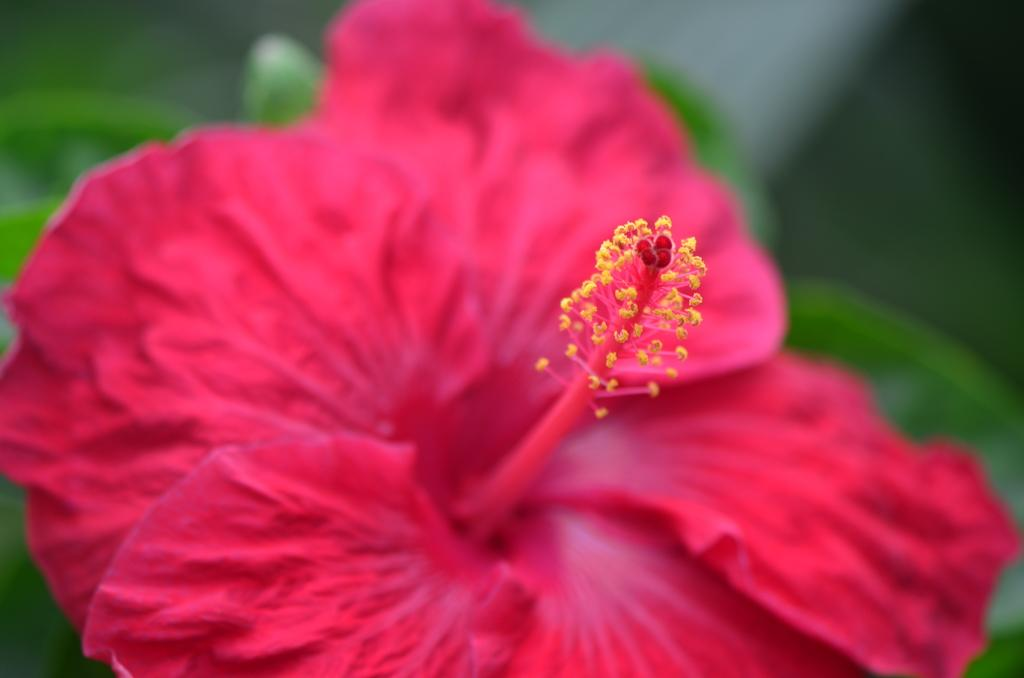What color is the flower in the image? The flower is red. Can you see a plane flying over the seashore in the image? There is no plane or seashore present in the image; it only features a red flower. 